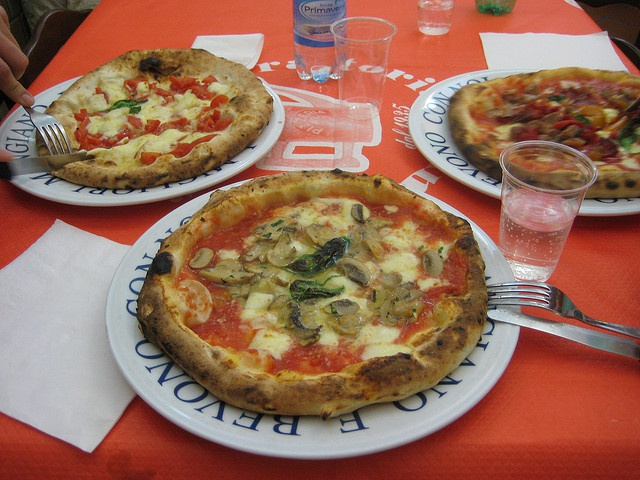Describe the objects in this image and their specific colors. I can see dining table in brown, darkgray, maroon, and tan tones, pizza in black, brown, tan, olive, and maroon tones, pizza in black, tan, brown, olive, and gray tones, pizza in black, maroon, brown, and tan tones, and cup in black, brown, and darkgray tones in this image. 